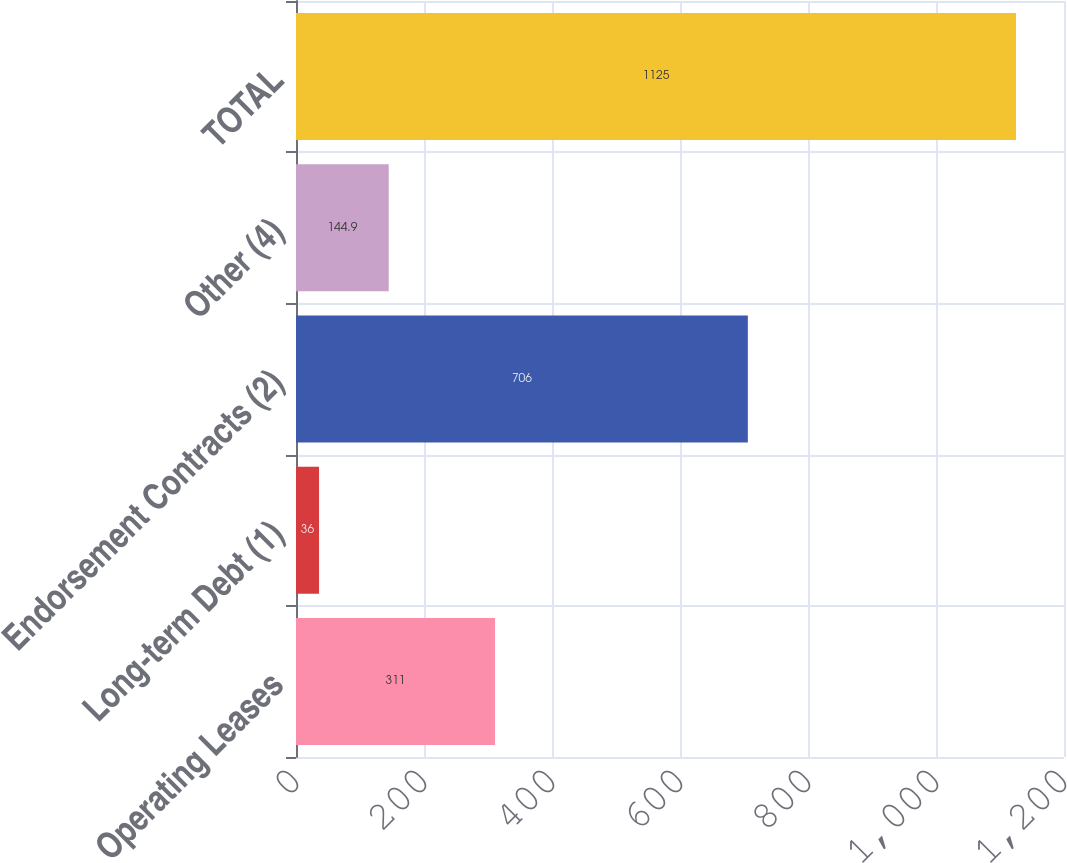Convert chart to OTSL. <chart><loc_0><loc_0><loc_500><loc_500><bar_chart><fcel>Operating Leases<fcel>Long-term Debt (1)<fcel>Endorsement Contracts (2)<fcel>Other (4)<fcel>TOTAL<nl><fcel>311<fcel>36<fcel>706<fcel>144.9<fcel>1125<nl></chart> 